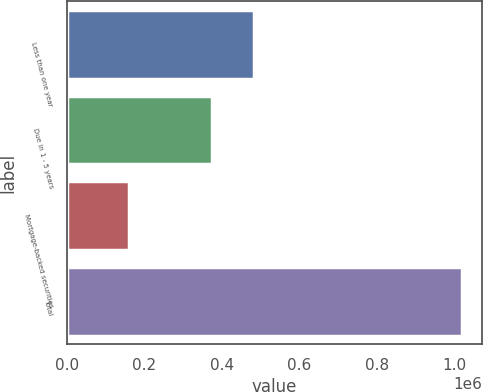Convert chart. <chart><loc_0><loc_0><loc_500><loc_500><bar_chart><fcel>Less than one year<fcel>Due in 1 - 5 years<fcel>Mortgage-backed securities<fcel>Total<nl><fcel>484616<fcel>374855<fcel>161199<fcel>1.02067e+06<nl></chart> 